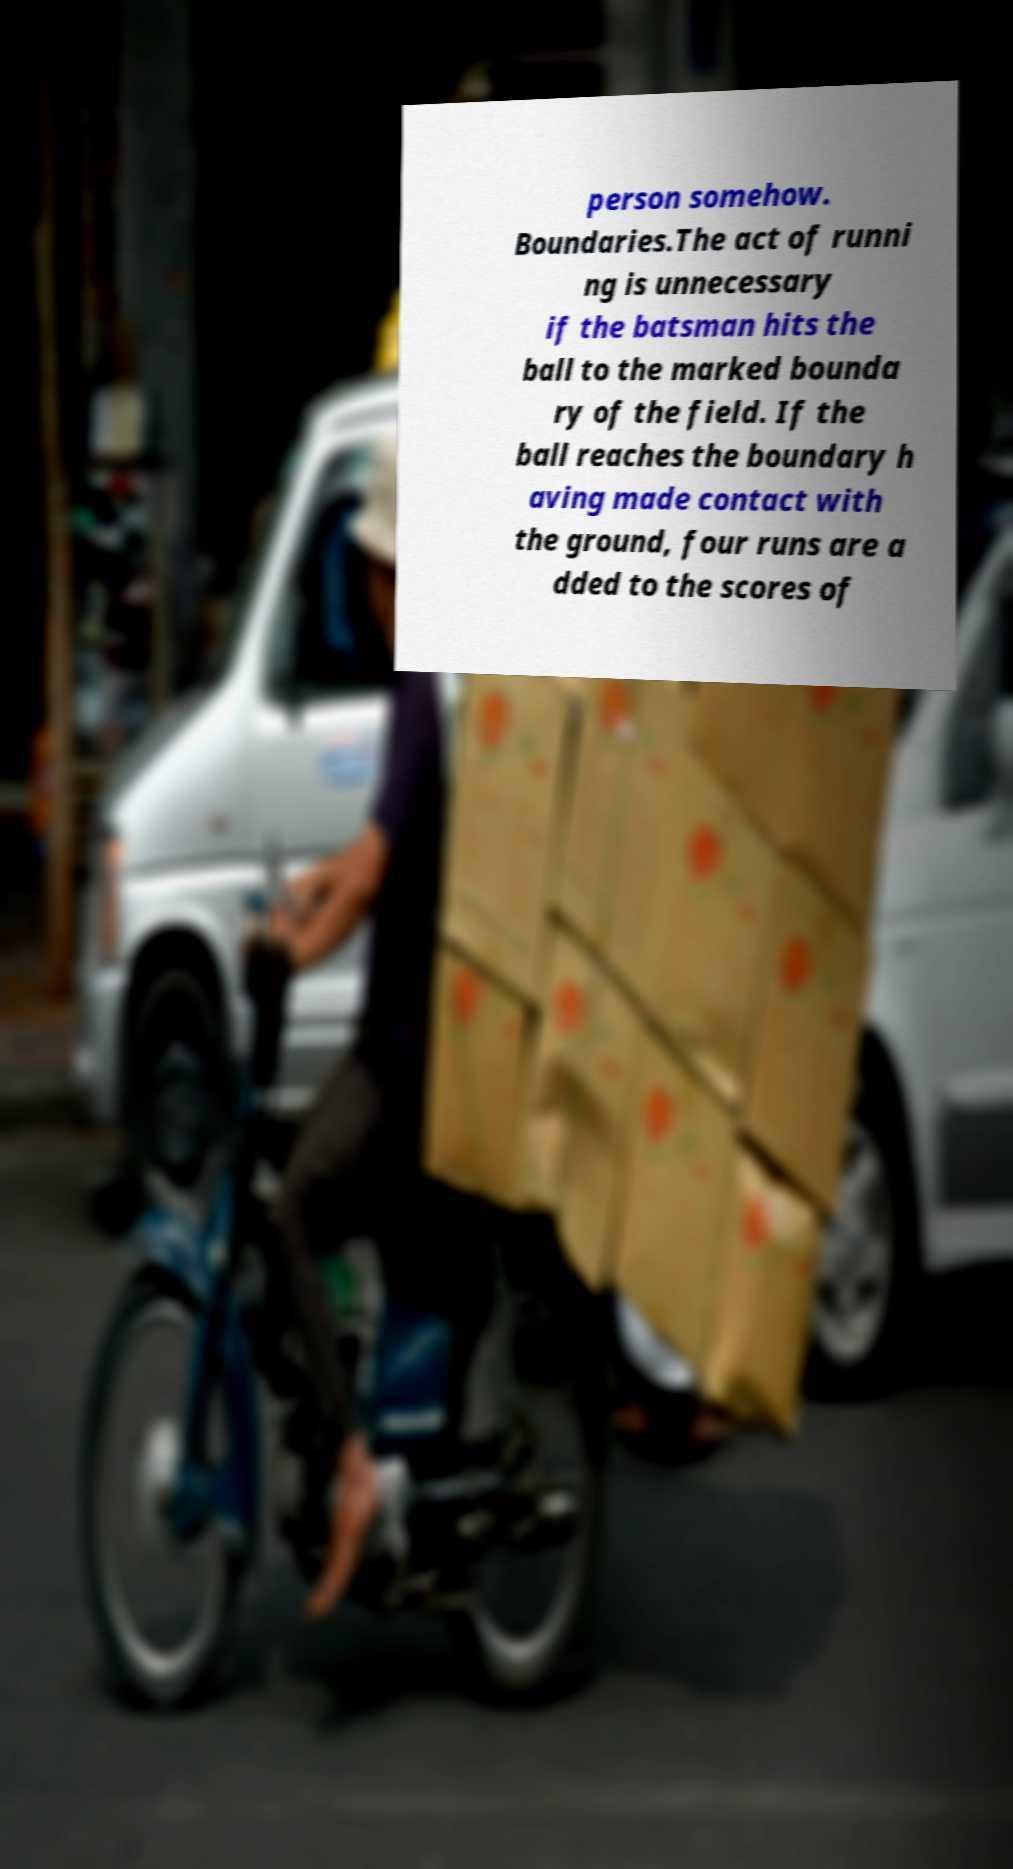Please identify and transcribe the text found in this image. person somehow. Boundaries.The act of runni ng is unnecessary if the batsman hits the ball to the marked bounda ry of the field. If the ball reaches the boundary h aving made contact with the ground, four runs are a dded to the scores of 